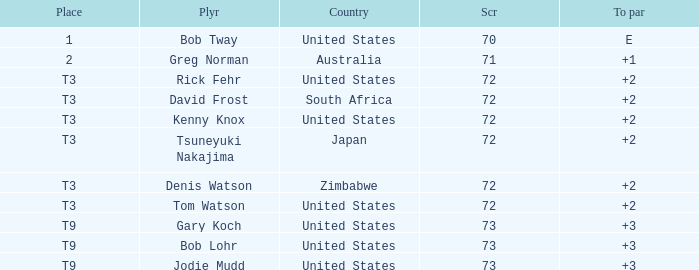Parse the full table. {'header': ['Place', 'Plyr', 'Country', 'Scr', 'To par'], 'rows': [['1', 'Bob Tway', 'United States', '70', 'E'], ['2', 'Greg Norman', 'Australia', '71', '+1'], ['T3', 'Rick Fehr', 'United States', '72', '+2'], ['T3', 'David Frost', 'South Africa', '72', '+2'], ['T3', 'Kenny Knox', 'United States', '72', '+2'], ['T3', 'Tsuneyuki Nakajima', 'Japan', '72', '+2'], ['T3', 'Denis Watson', 'Zimbabwe', '72', '+2'], ['T3', 'Tom Watson', 'United States', '72', '+2'], ['T9', 'Gary Koch', 'United States', '73', '+3'], ['T9', 'Bob Lohr', 'United States', '73', '+3'], ['T9', 'Jodie Mudd', 'United States', '73', '+3']]} What is the low score for TO par +2 in japan? 72.0. 